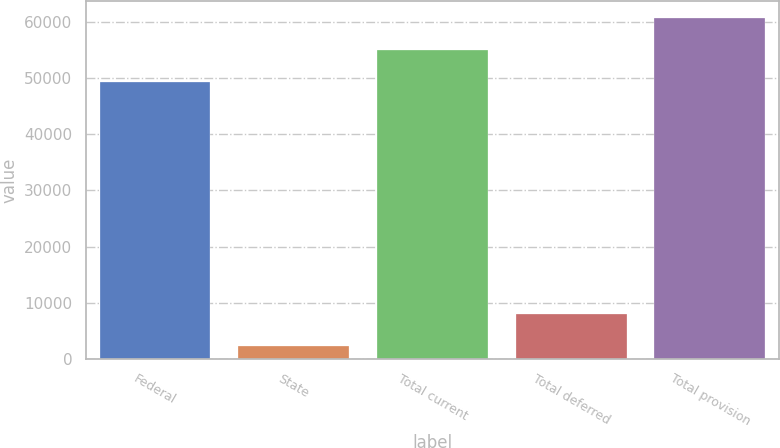Convert chart. <chart><loc_0><loc_0><loc_500><loc_500><bar_chart><fcel>Federal<fcel>State<fcel>Total current<fcel>Total deferred<fcel>Total provision<nl><fcel>49395<fcel>2321<fcel>55039.2<fcel>7965.2<fcel>60683.4<nl></chart> 